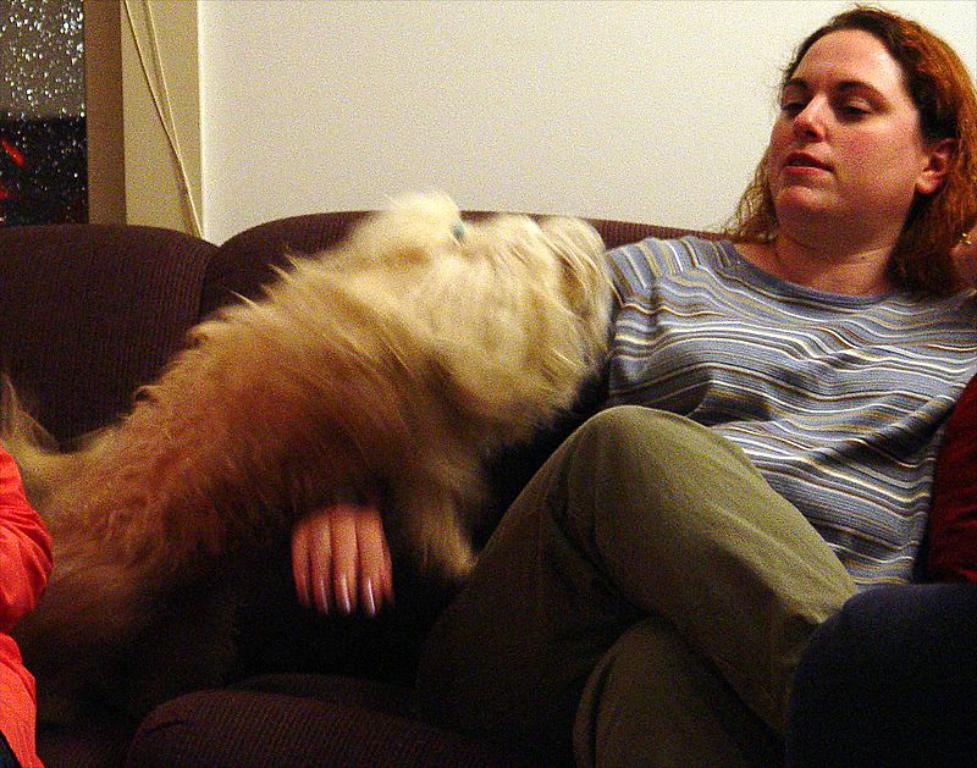What is the main subject of the image? The main subject of the image is a woman. What is the woman doing in the image? The woman is sitting on a sofa. Is there any other living creature present in the image? Yes, there is a dog in the image. Where is the dog positioned in relation to the woman? The dog is on the woman's right side. What type of bubble can be seen floating in the air in the image? There is no bubble present in the image. What kind of fish can be seen swimming in the background of the image? There is no fish present in the image. 